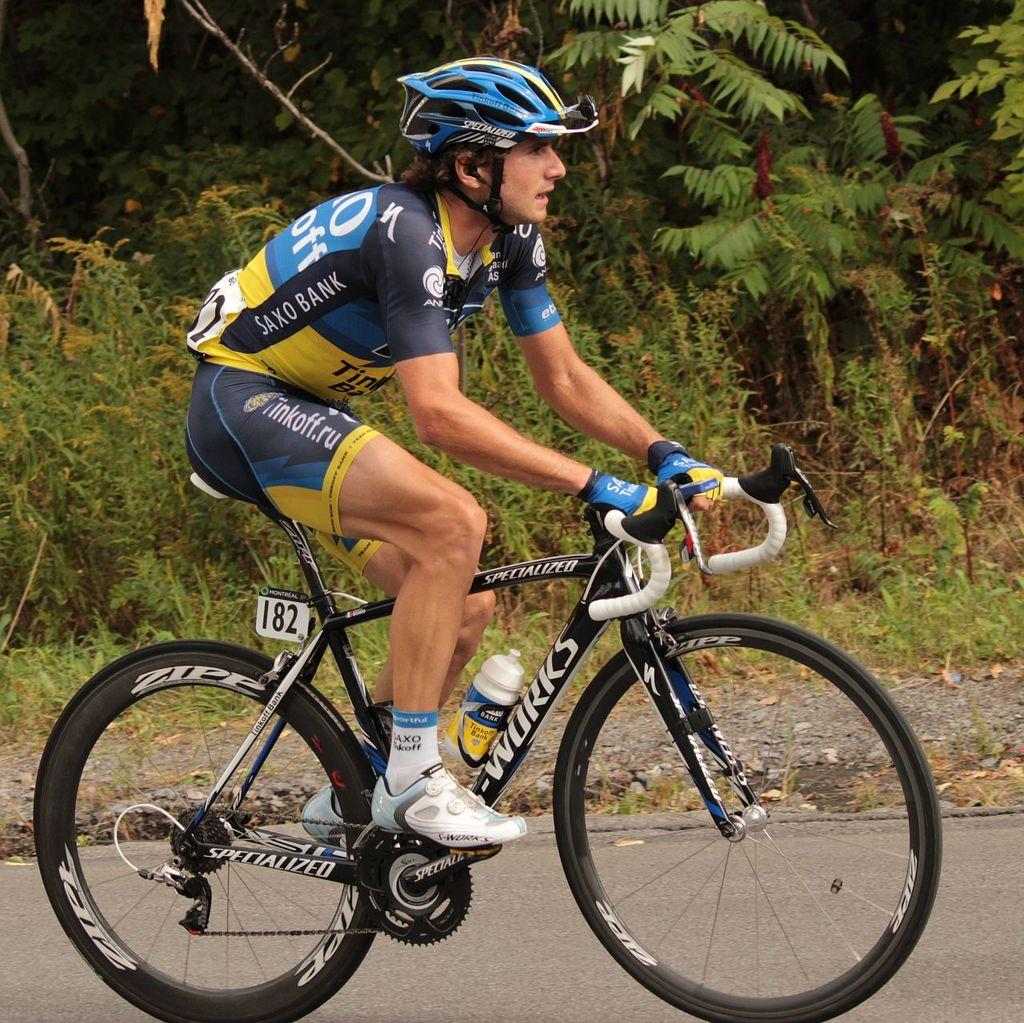What is the main subject of the image? There is a person in the image. What is the person doing in the image? The person is sitting on a bicycle. What is the position of the bicycle in the image? The bicycle is placed on the ground. What safety gear is the person wearing in the image? The person is wearing a helmet. What can be seen in the background of the image? There is a group of trees in the background of the image. What type of soup is the person eating in the image? There is no soup present in the image; the person is sitting on a bicycle. 